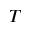<formula> <loc_0><loc_0><loc_500><loc_500>T</formula> 